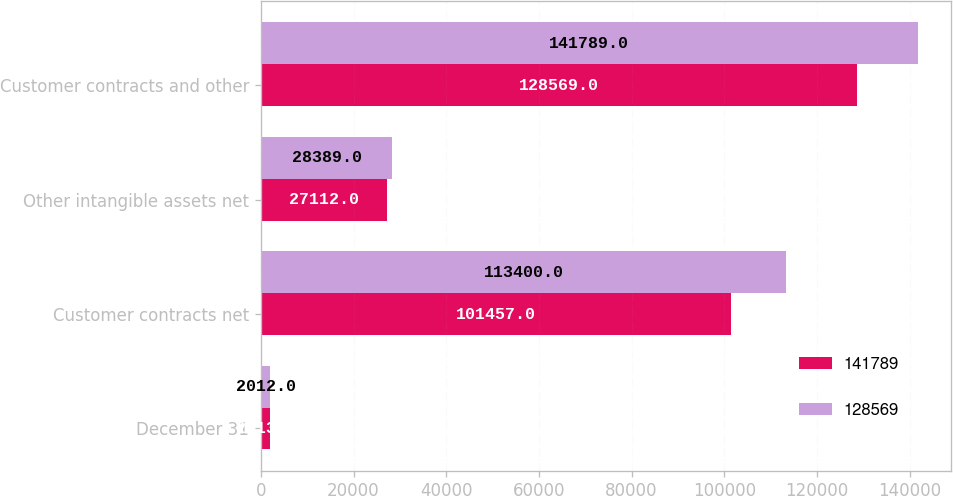Convert chart. <chart><loc_0><loc_0><loc_500><loc_500><stacked_bar_chart><ecel><fcel>December 31<fcel>Customer contracts net<fcel>Other intangible assets net<fcel>Customer contracts and other<nl><fcel>141789<fcel>2013<fcel>101457<fcel>27112<fcel>128569<nl><fcel>128569<fcel>2012<fcel>113400<fcel>28389<fcel>141789<nl></chart> 